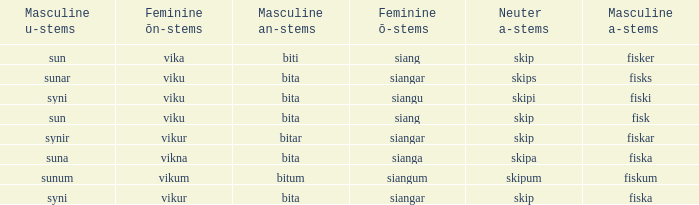What is the an-stem for the word which has an ö-stems of siangar and an u-stem ending of syni? Bita. 